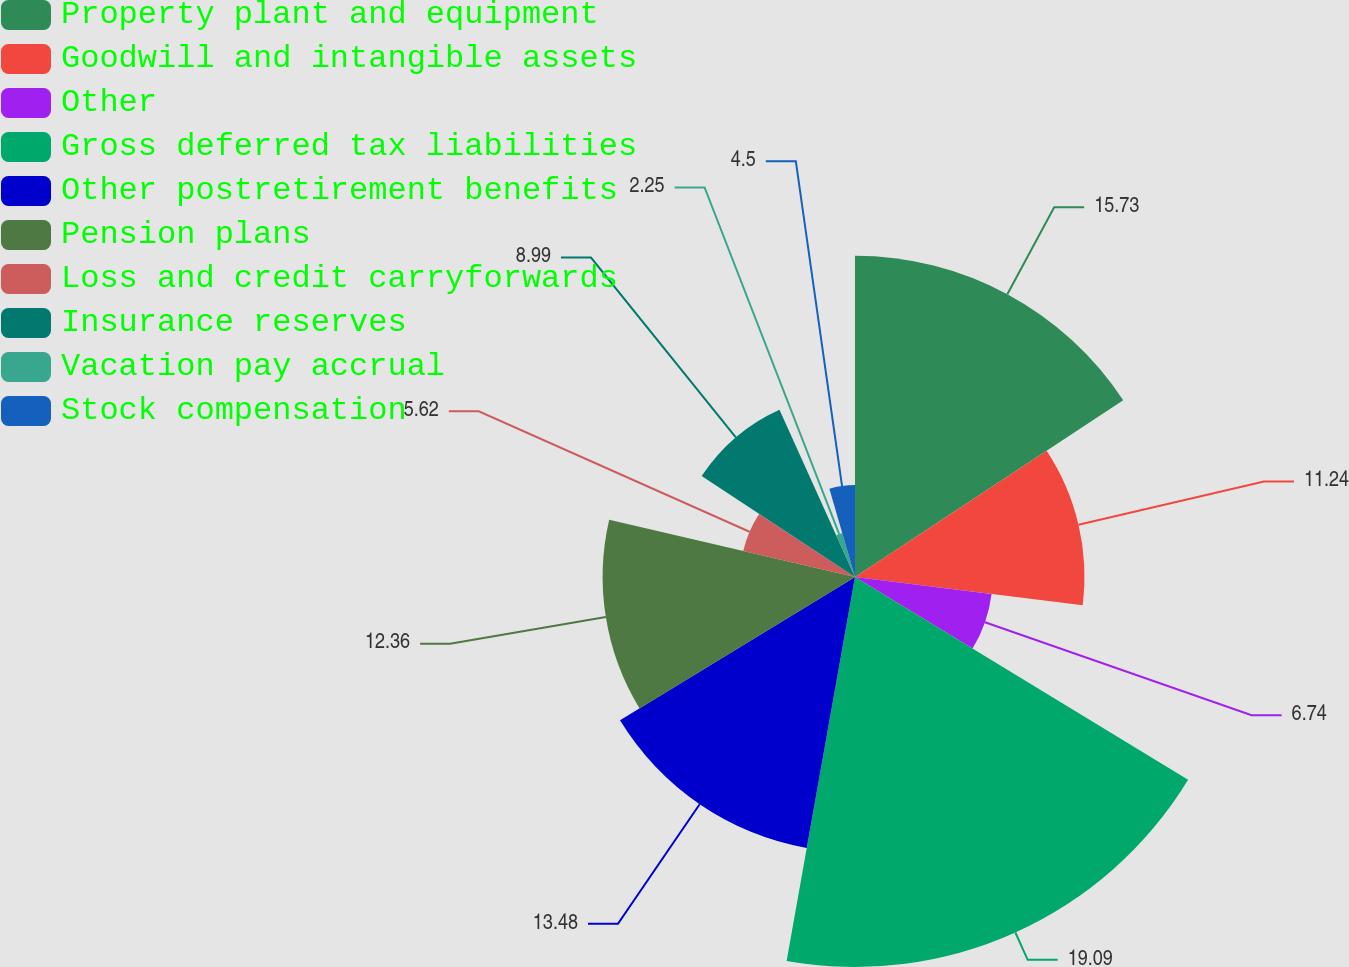Convert chart to OTSL. <chart><loc_0><loc_0><loc_500><loc_500><pie_chart><fcel>Property plant and equipment<fcel>Goodwill and intangible assets<fcel>Other<fcel>Gross deferred tax liabilities<fcel>Other postretirement benefits<fcel>Pension plans<fcel>Loss and credit carryforwards<fcel>Insurance reserves<fcel>Vacation pay accrual<fcel>Stock compensation<nl><fcel>15.73%<fcel>11.24%<fcel>6.74%<fcel>19.1%<fcel>13.48%<fcel>12.36%<fcel>5.62%<fcel>8.99%<fcel>2.25%<fcel>4.5%<nl></chart> 